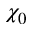<formula> <loc_0><loc_0><loc_500><loc_500>\chi _ { 0 }</formula> 